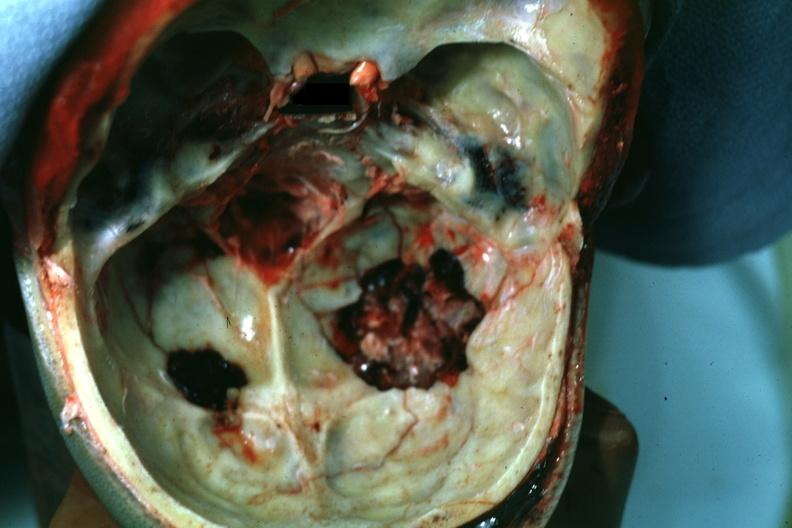s bone, calvarium present?
Answer the question using a single word or phrase. Yes 